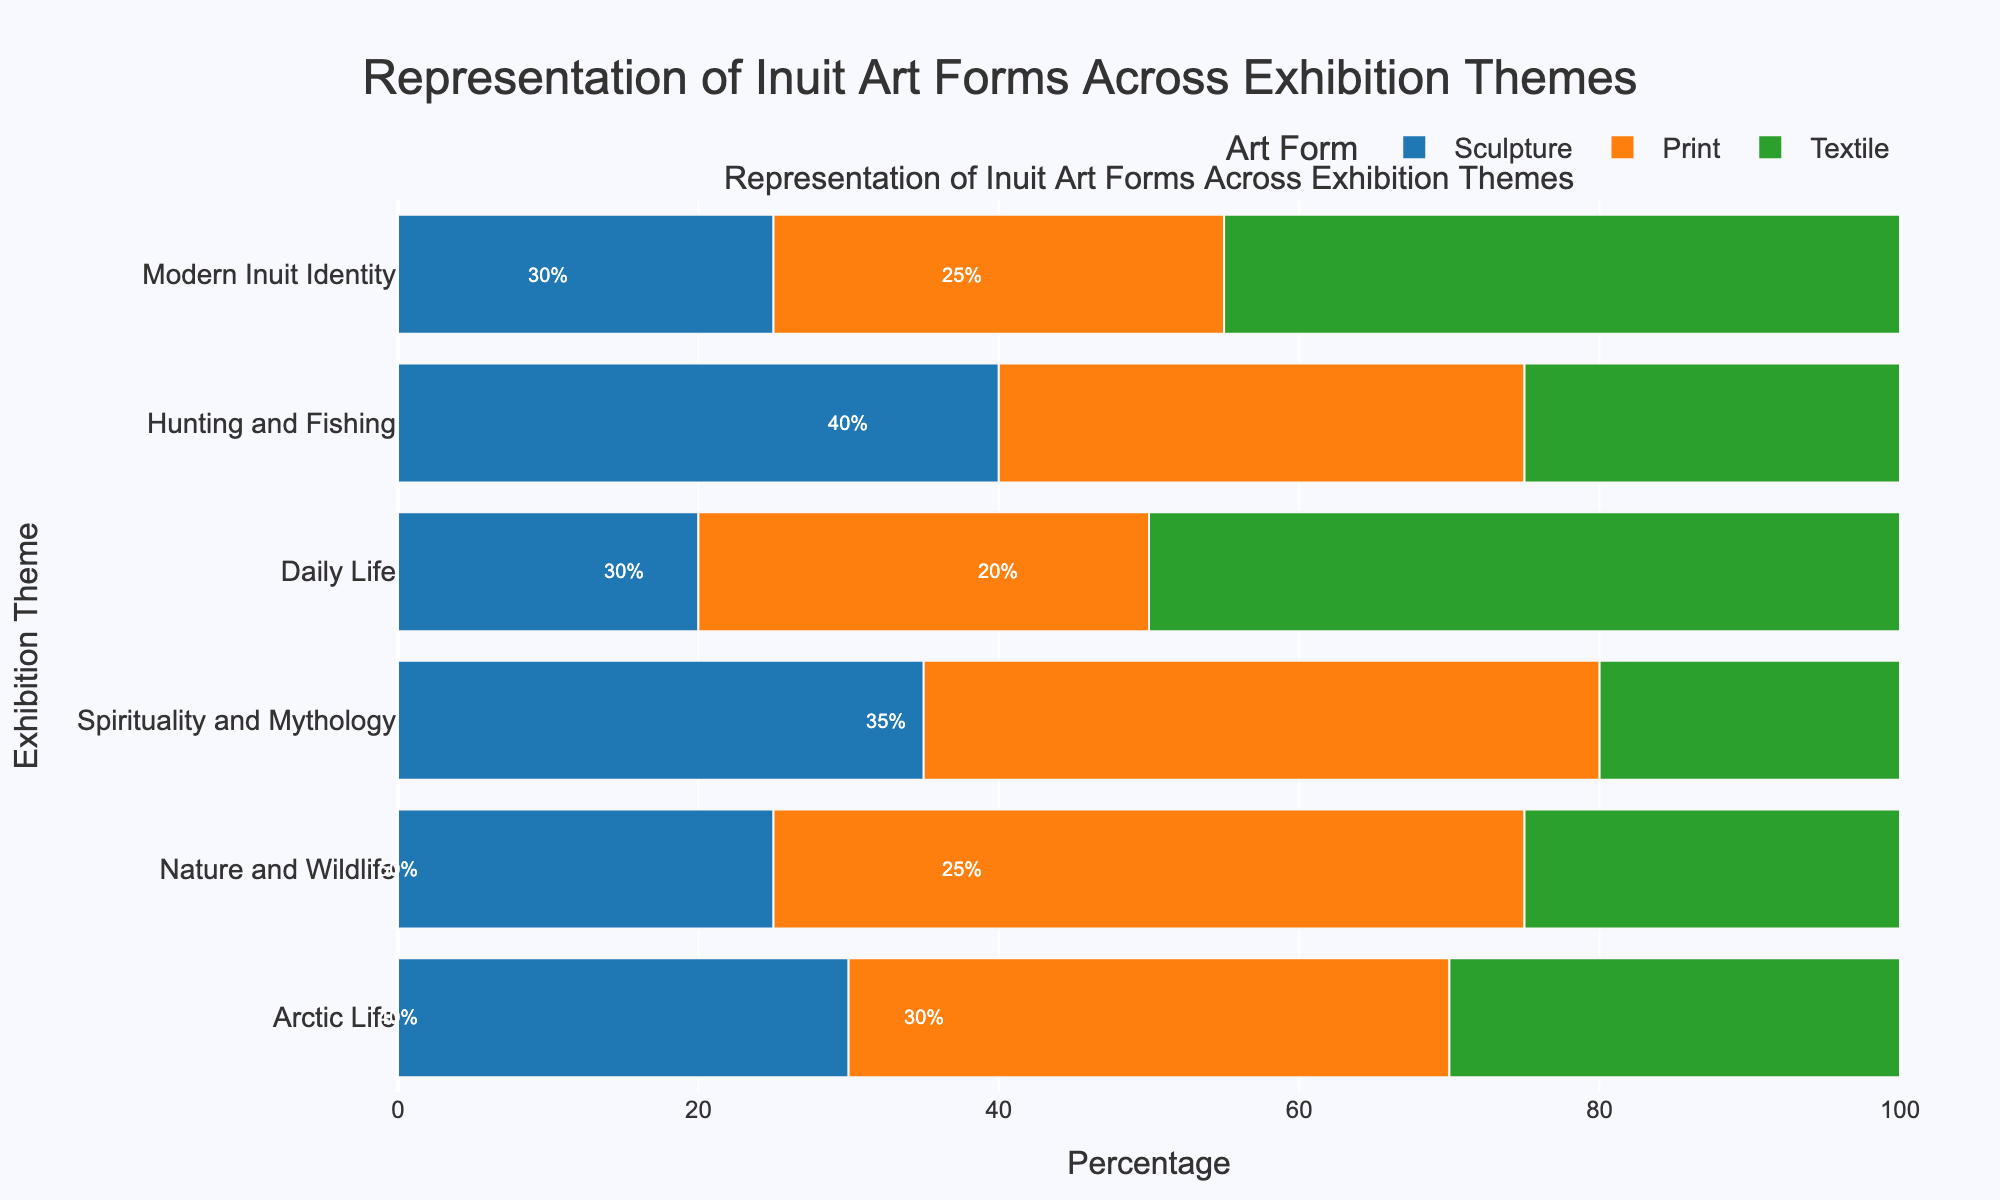Which exhibition theme has the highest representation of textile art? In the chart, the theme "Daily Life" shows a bar of 50% for textiles, which is higher than textile representations in other themes.
Answer: Daily Life How does the representation of sculpture compare to print in the "Arctic Life" theme? For the "Arctic Life" theme, the sculpture representation is at 30% while the print representation is at 40%. Therefore, print has a higher representation than sculpture in the "Arctic Life" theme by 10%.
Answer: Print is 10% higher What is the total percentage of representation for each art form in the "Hunting and Fishing" theme? In the "Hunting and Fishing" theme, sculpture is at 40%, print is at 35%, and textile is at 25%. Adding these, 40% + 35% + 25% = 100%.
Answer: 100% Which theme has the smallest percentage of textile representation, and what is the value? On the chart, the "Spirituality and Mythology" theme has the smallest textile representation, marked at 20%.
Answer: Spirituality and Mythology, 20% Between "Nature and Wildlife" and "Modern Inuit Identity," which has a higher combined representation of sculpture and print? Adding sculpture and print in "Nature and Wildlife": 25% + 50% = 75%. Adding sculpture and print in "Modern Inuit Identity": 25% + 30% = 55%. Thus, "Nature and Wildlife" has a higher combined representation.
Answer: Nature and Wildlife, 75% What is the average percentage of sculpture representation across all themes? Sum the sculpture percentages: 30% + 25% + 35% + 20% + 40% + 25% = 175%. Since there are six themes, the average is 175% / 6 = 29.17%.
Answer: 29.17% How does the longest bar in the "Spirituality and Mythology" theme compare in length to the shortest bar in the "Hunting and Fishing" theme? The longest bar for "Spirituality and Mythology" is print at 45%, and the shortest bar for "Hunting and Fishing" is textile at 25%. Therefore, the longest bar in "Spirituality and Mythology" is 20% longer than the shortest bar in "Hunting and Fishing".
Answer: 20% longer Which theme has the most even distribution of art forms? Looking at the bars, "Arctic Life" has sculpture, print, and textile all around 30% to 40%. This is more even compared to other themes where one art form significantly dominates.
Answer: Arctic Life 